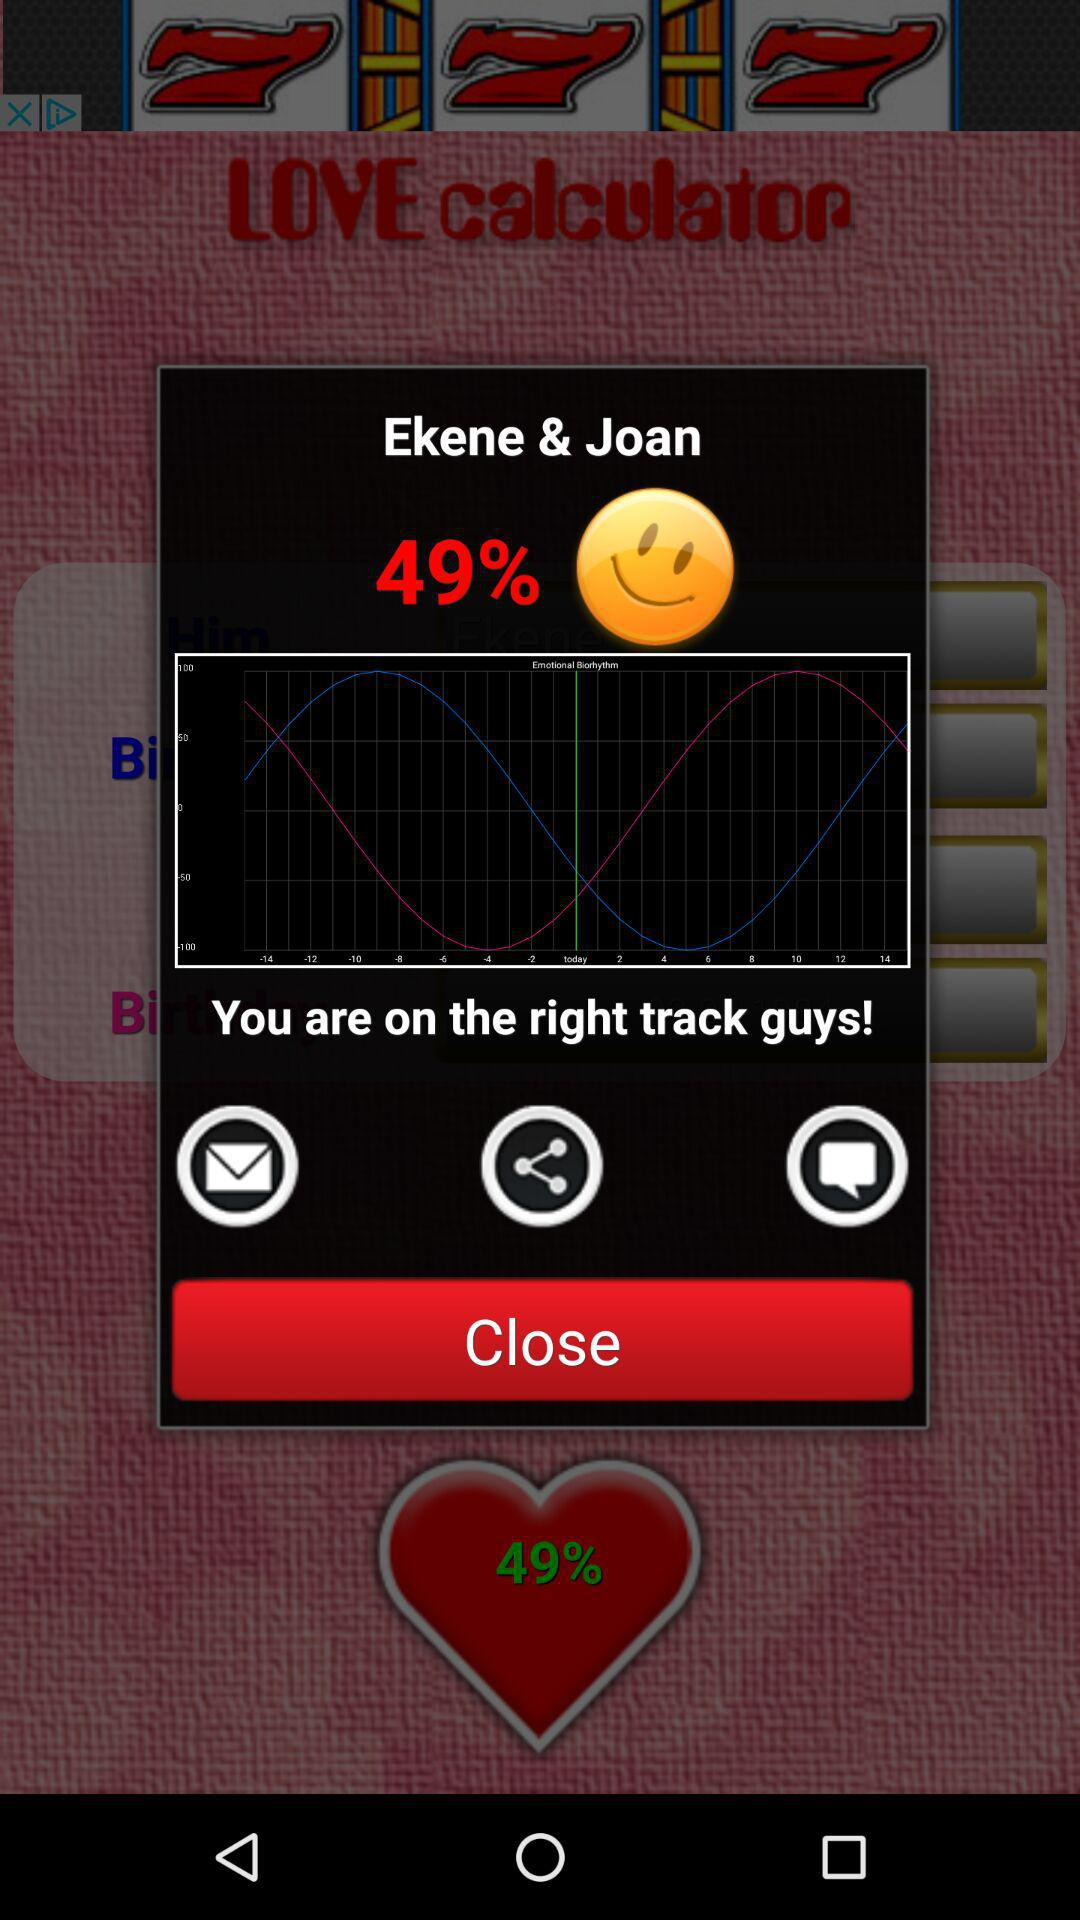How much is the percentage? The percentage is 49. 